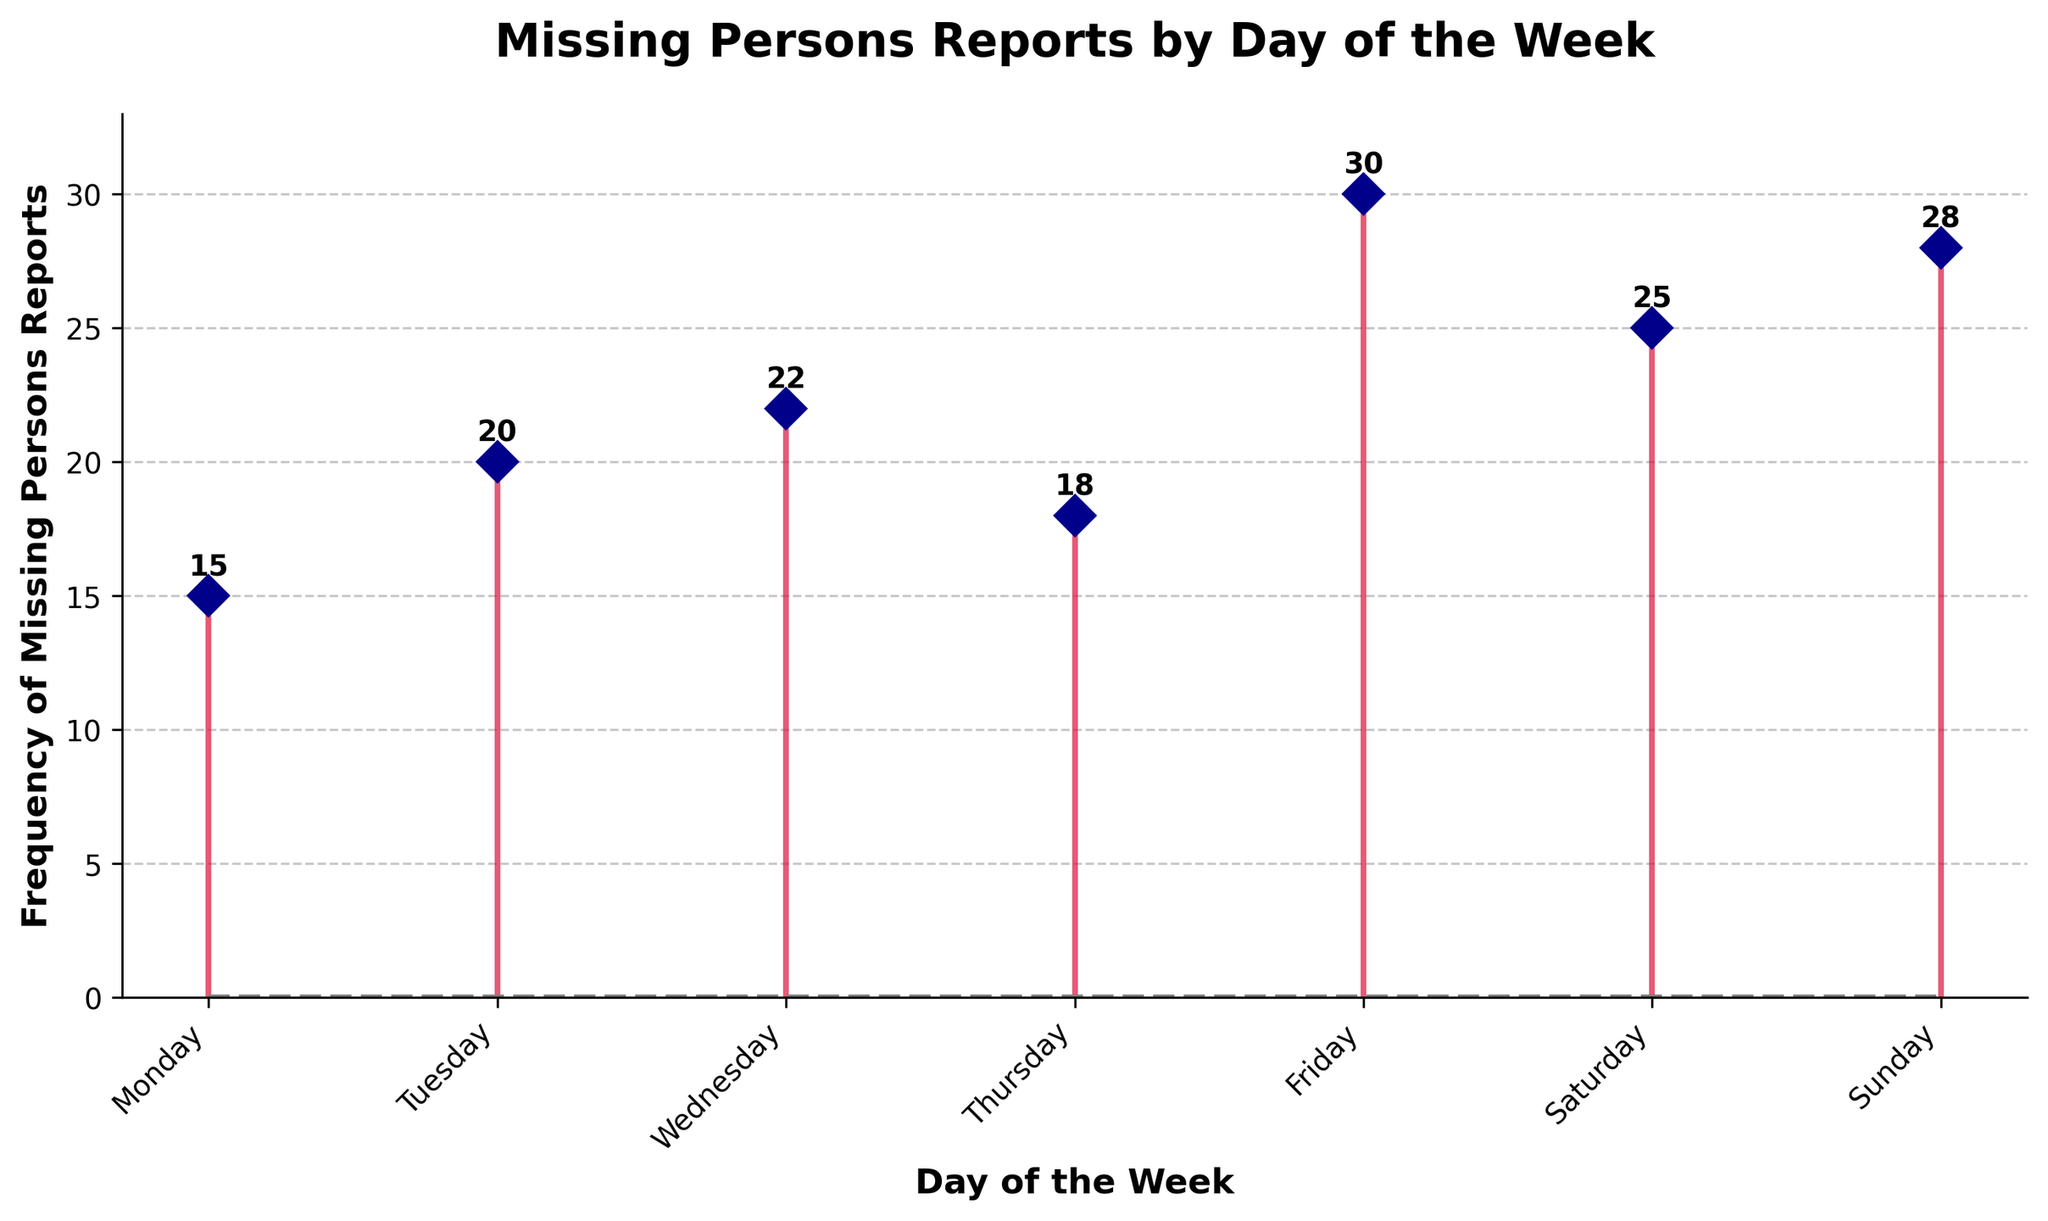What is the title of the plot? The title can be found at the top of the plot, which provides a summary of what the data represents.
Answer: Missing Persons Reports by Day of the Week Which day has the highest frequency of missing persons reports? The highest frequency can be identified by finding the tallest stem in the plot. The annotation on the top of the stems will help.
Answer: Friday What is the frequency of missing persons reports on Wednesday? Locate 'Wednesday' on the horizontal axis and check the number listed above its respective stem.
Answer: 22 What is the difference in frequency between Tuesday and Thursday? Find the frequencies for Tuesday (20) and Thursday (18). Subtract the smaller number from the larger to get the difference.
Answer: 2 What is the average frequency of missing persons reports throughout the week? Sum all frequencies (15 + 20 + 22 + 18 + 30 + 25 + 28 = 158) and divide by the number of days (7).
Answer: 22.57 Which day has the lowest frequency of missing persons reports? The lowest frequency can be identified by finding the shortest stem in the plot. The annotation on the top of the stems will help.
Answer: Monday How does the frequency on Sunday compare to the frequency on Saturday? Find the frequencies for Sunday (28) and Saturday (25), then compare them to see that Sunday has a higher frequency.
Answer: Sunday has a higher frequency What is the total frequency of missing persons reports from Monday to Wednesday? Sum the frequencies for Monday (15), Tuesday (20), and Wednesday (22).
Answer: 57 Is there a noticeable trend in the frequency of missing persons reports as the week progresses? By observing the overall pattern of the stems, check whether the frequencies increase, decrease, or fluctuate throughout the week.
Answer: Frequencies generally increase towards the weekend How many days have a frequency of missing persons reports greater than 20? Count the days whose stems exceed the 20 mark on the vertical axis (Wednesday, Friday, Saturday, and Sunday).
Answer: 4 